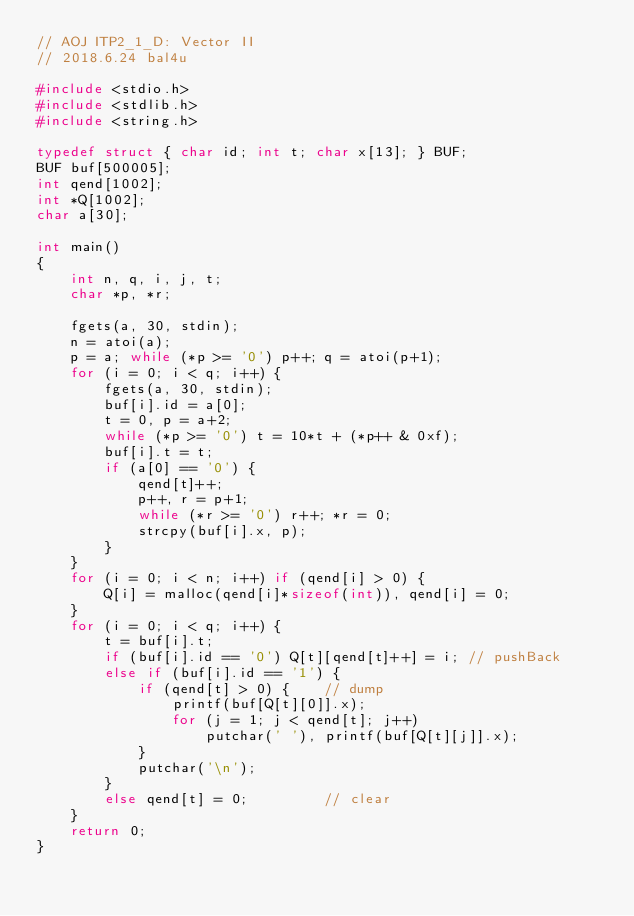<code> <loc_0><loc_0><loc_500><loc_500><_C_>// AOJ ITP2_1_D: Vector II
// 2018.6.24 bal4u

#include <stdio.h>
#include <stdlib.h>
#include <string.h>

typedef struct { char id; int t; char x[13]; } BUF;
BUF buf[500005];
int qend[1002];
int *Q[1002];
char a[30];

int main()
{
	int n, q, i, j, t;
	char *p, *r;
	
	fgets(a, 30, stdin);
	n = atoi(a);
	p = a; while (*p >= '0') p++; q = atoi(p+1);
	for (i = 0; i < q; i++) {
		fgets(a, 30, stdin);
		buf[i].id = a[0];
		t = 0, p = a+2;
		while (*p >= '0') t = 10*t + (*p++ & 0xf);
		buf[i].t = t;
		if (a[0] == '0') {
			qend[t]++;
			p++, r = p+1;
			while (*r >= '0') r++; *r = 0;
			strcpy(buf[i].x, p);
		}
	}
	for (i = 0; i < n; i++) if (qend[i] > 0) {
		Q[i] = malloc(qend[i]*sizeof(int)), qend[i] = 0;
	}
	for (i = 0; i < q; i++) {
		t = buf[i].t;
		if (buf[i].id == '0') Q[t][qend[t]++] = i; // pushBack
		else if (buf[i].id == '1') {
			if (qend[t] > 0) {    // dump
				printf(buf[Q[t][0]].x);
				for (j = 1; j < qend[t]; j++)
					putchar(' '), printf(buf[Q[t][j]].x);
			}
			putchar('\n');
		}
		else qend[t] = 0;         // clear
	}
	return 0;
}
</code> 